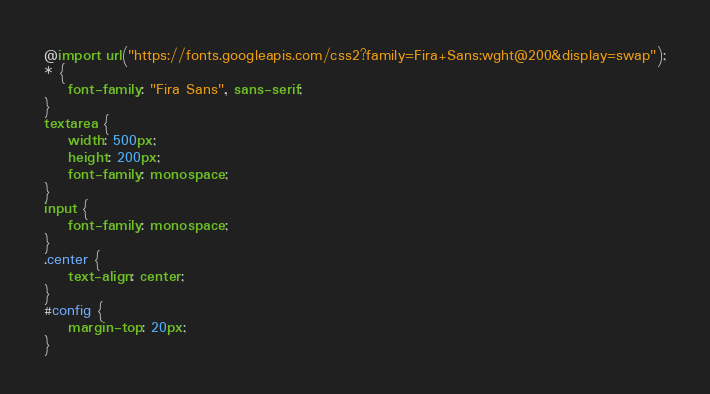Convert code to text. <code><loc_0><loc_0><loc_500><loc_500><_CSS_>@import url("https://fonts.googleapis.com/css2?family=Fira+Sans:wght@200&display=swap");
* {
    font-family: "Fira Sans", sans-serif;
}
textarea {
    width: 500px;
    height: 200px;
    font-family: monospace;
}
input {
    font-family: monospace;
}
.center {
    text-align: center;
}
#config {
    margin-top: 20px;
}</code> 